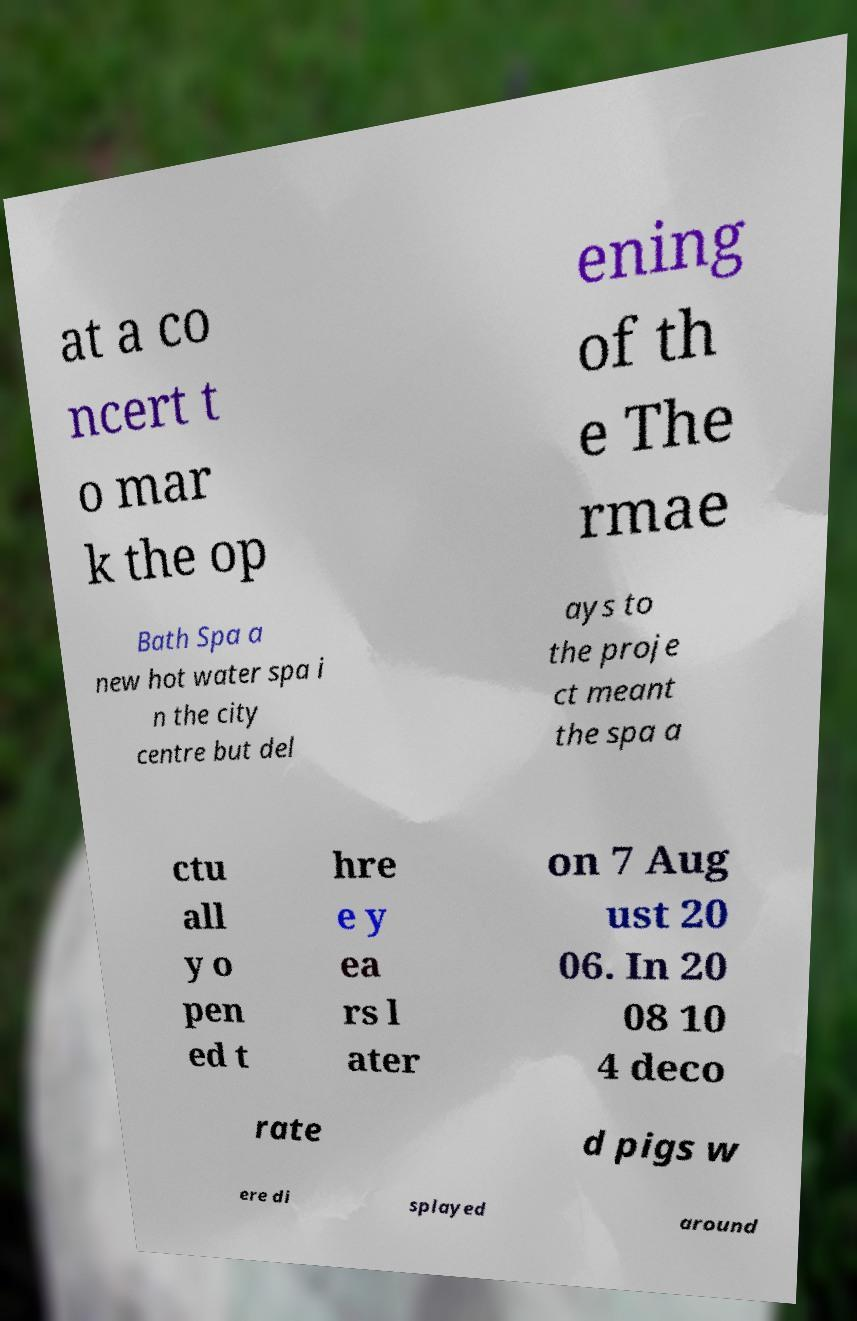What messages or text are displayed in this image? I need them in a readable, typed format. at a co ncert t o mar k the op ening of th e The rmae Bath Spa a new hot water spa i n the city centre but del ays to the proje ct meant the spa a ctu all y o pen ed t hre e y ea rs l ater on 7 Aug ust 20 06. In 20 08 10 4 deco rate d pigs w ere di splayed around 